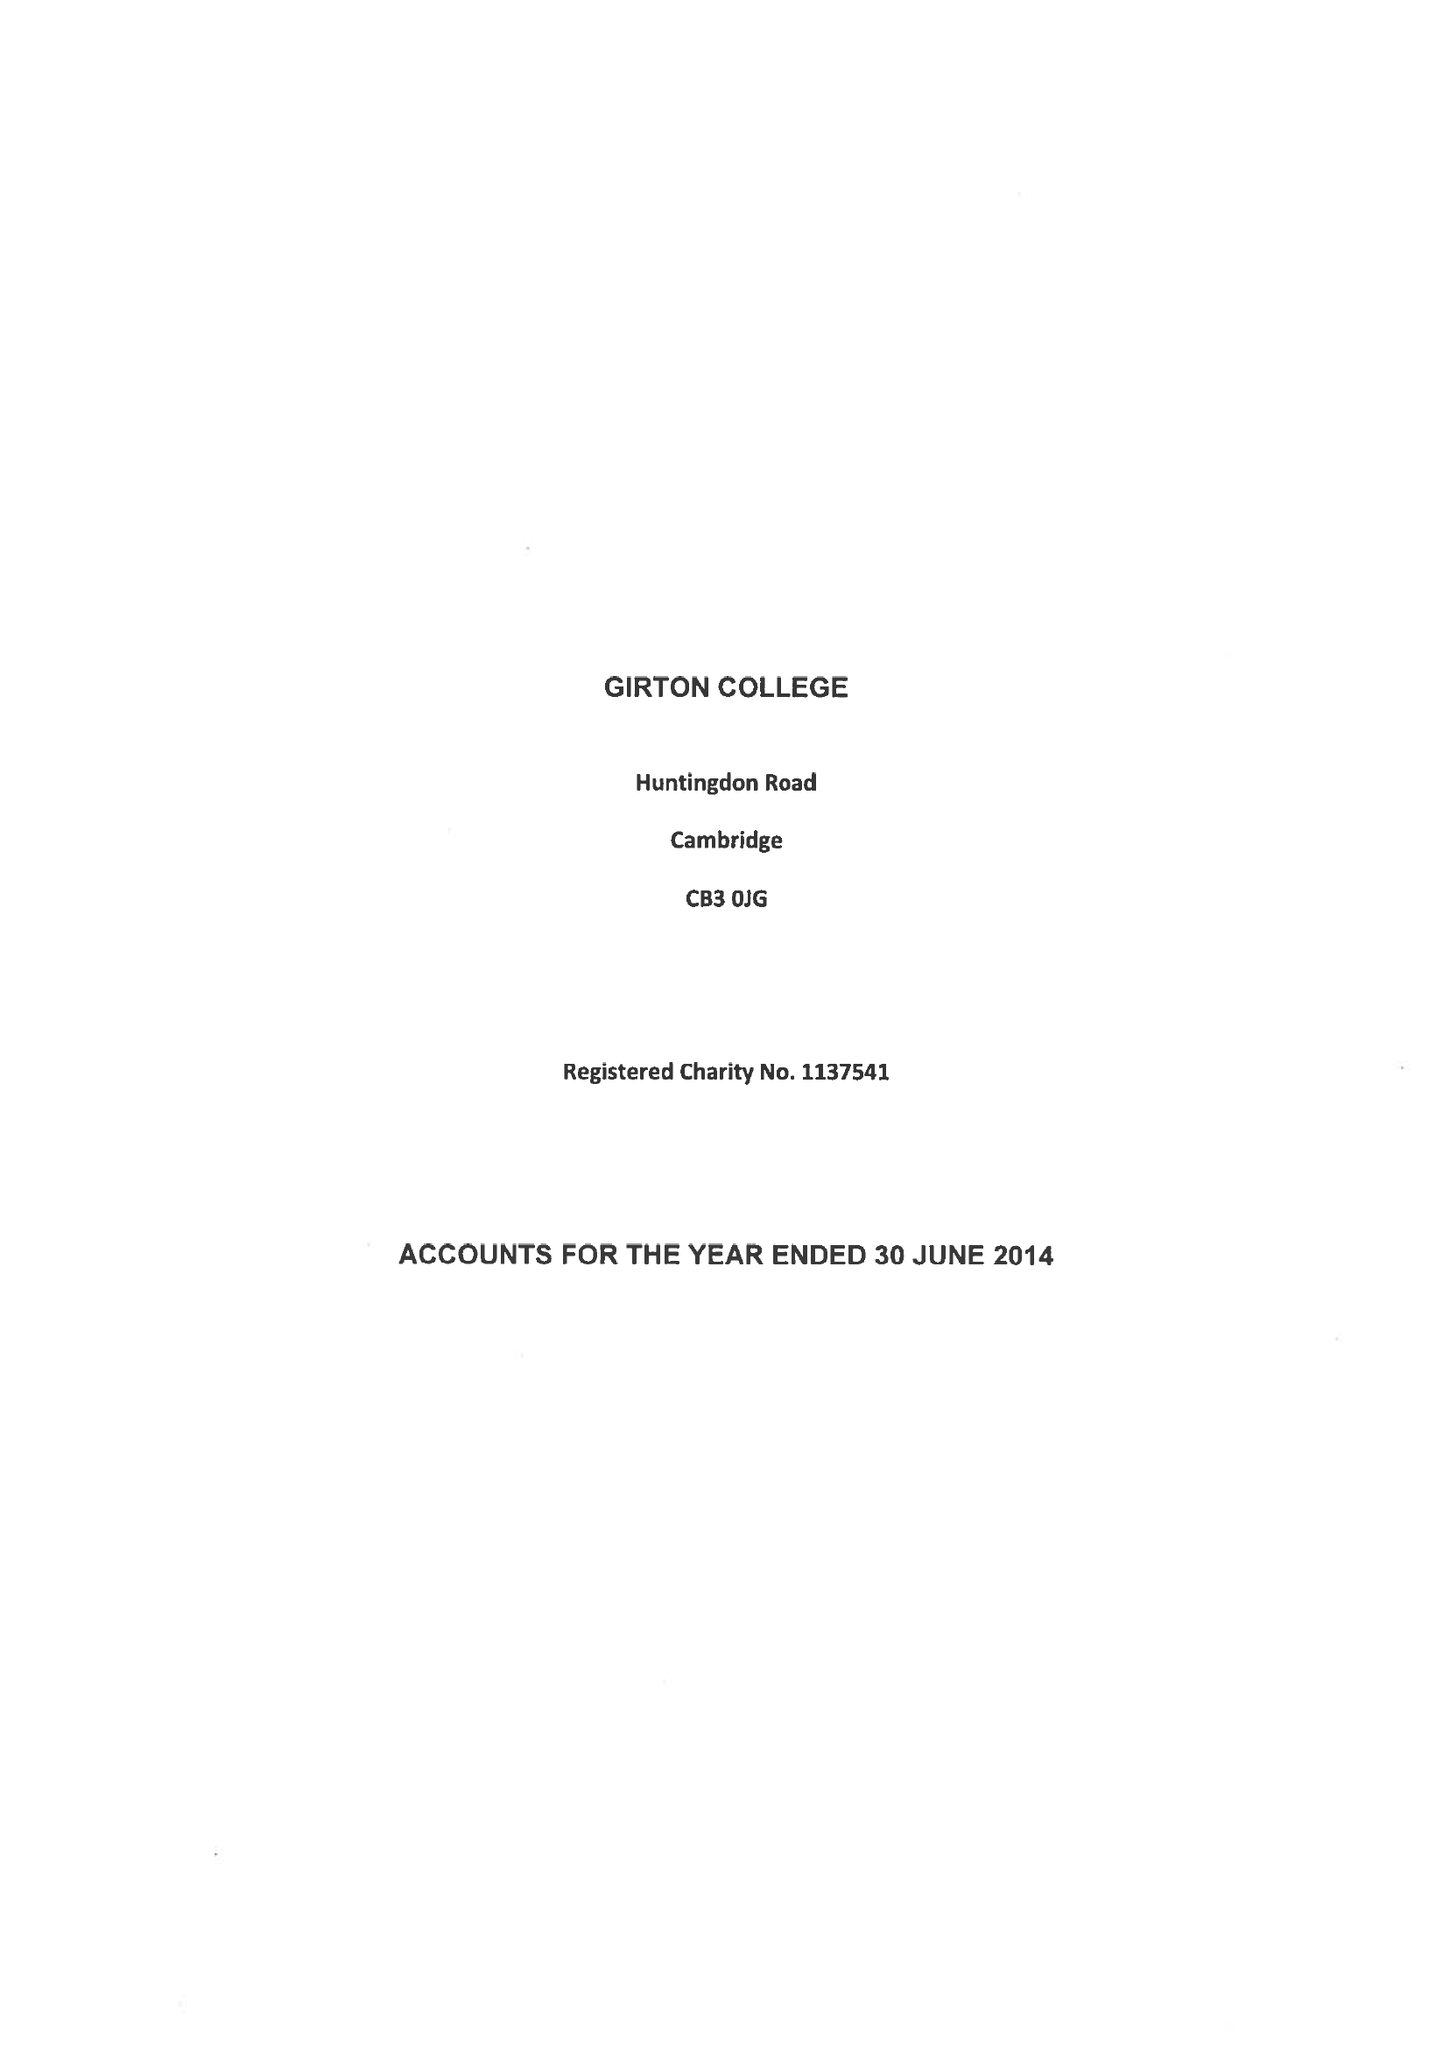What is the value for the charity_name?
Answer the question using a single word or phrase. Girton College 